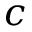<formula> <loc_0><loc_0><loc_500><loc_500>c</formula> 